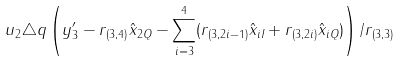Convert formula to latex. <formula><loc_0><loc_0><loc_500><loc_500>u _ { 2 } \triangle q \left ( y _ { 3 } ^ { \prime } - r _ { ( 3 , 4 ) } \hat { x } _ { 2 Q } - \sum _ { i = 3 } ^ { 4 } ( r _ { ( 3 , 2 i - 1 ) } \hat { x } _ { i I } + r _ { ( 3 , 2 i ) } \hat { x } _ { i Q } ) \right ) / r _ { ( 3 , 3 ) }</formula> 